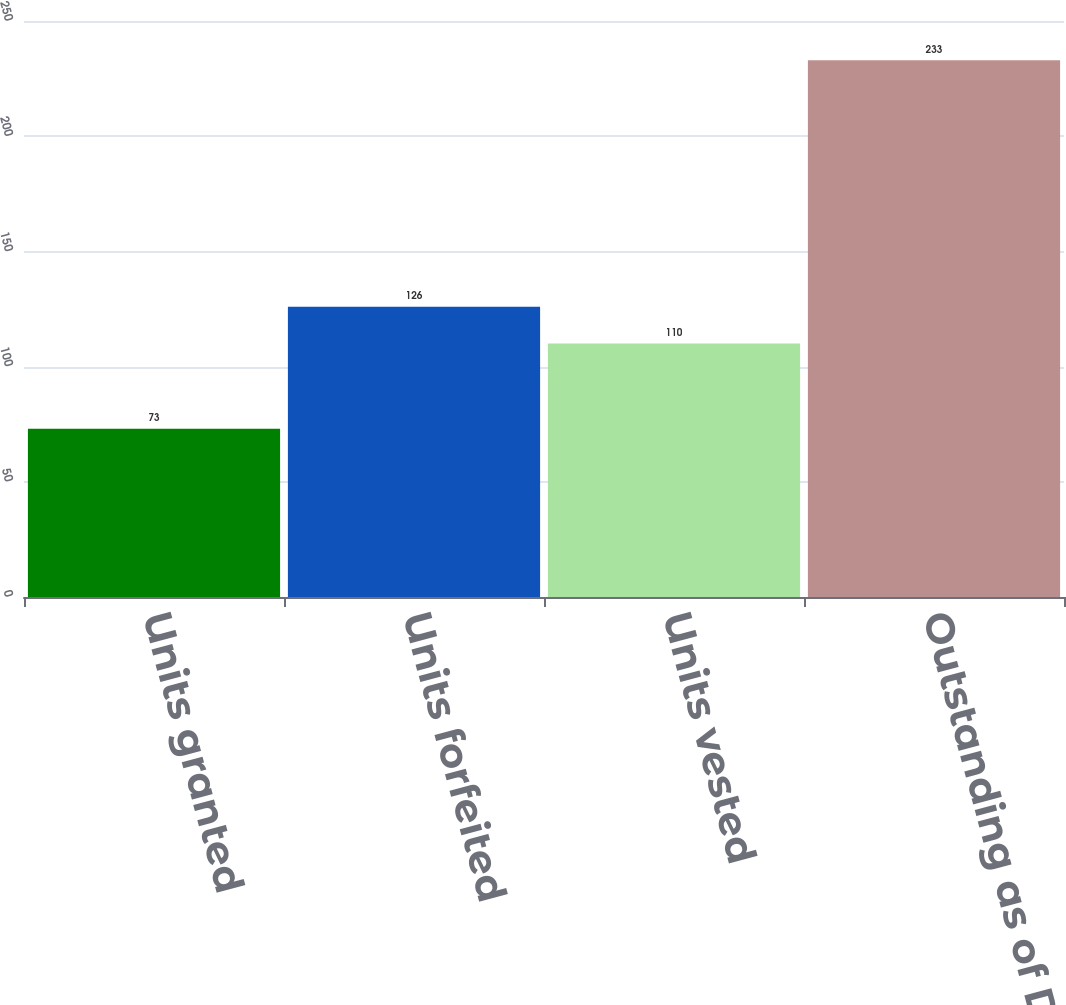Convert chart. <chart><loc_0><loc_0><loc_500><loc_500><bar_chart><fcel>Units granted<fcel>Units forfeited<fcel>Units vested<fcel>Outstanding as of December 31<nl><fcel>73<fcel>126<fcel>110<fcel>233<nl></chart> 